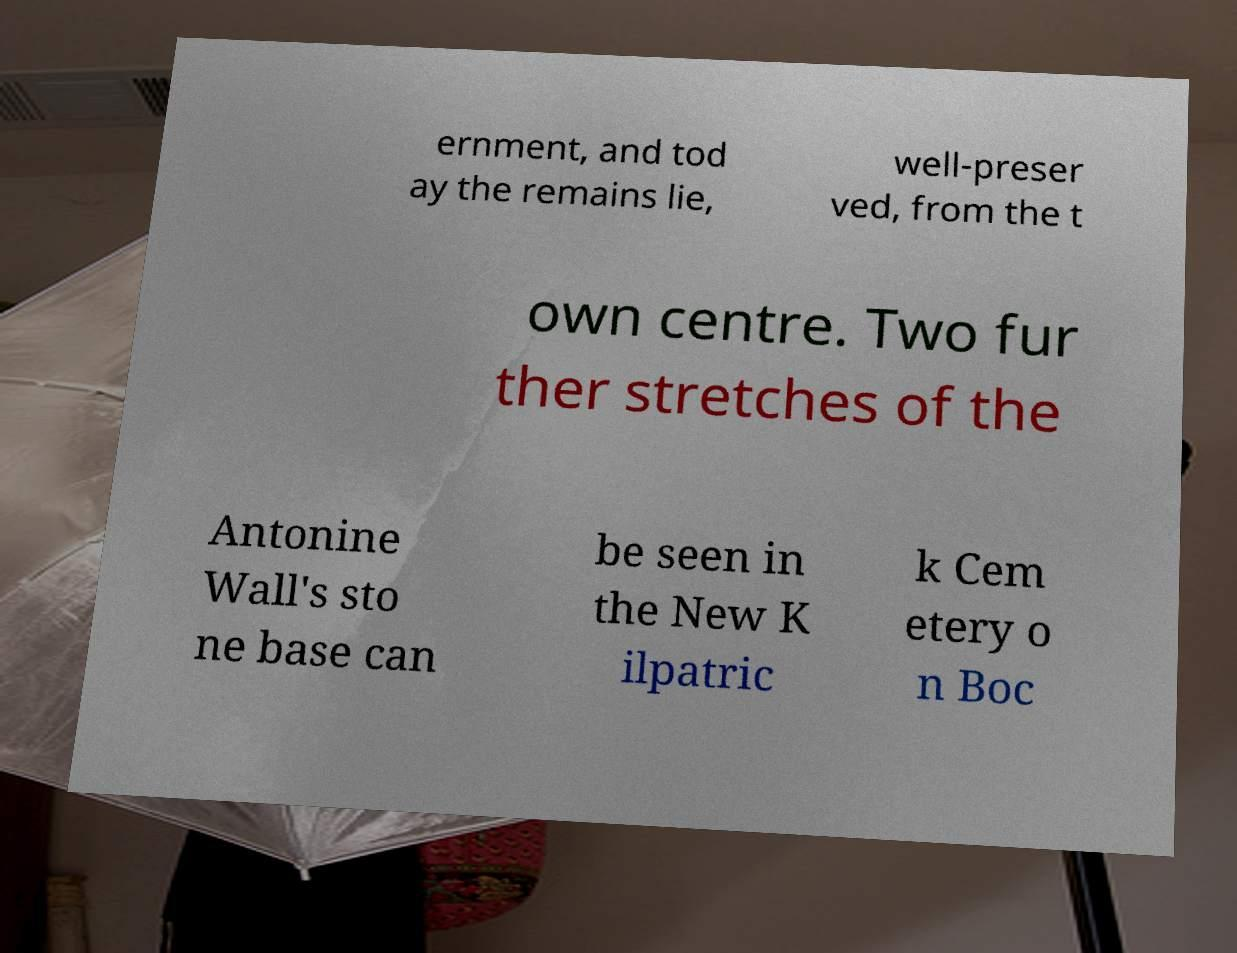Could you extract and type out the text from this image? ernment, and tod ay the remains lie, well-preser ved, from the t own centre. Two fur ther stretches of the Antonine Wall's sto ne base can be seen in the New K ilpatric k Cem etery o n Boc 